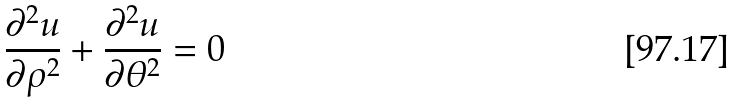Convert formula to latex. <formula><loc_0><loc_0><loc_500><loc_500>\frac { \partial ^ { 2 } u } { \partial \rho ^ { 2 } } + \frac { \partial ^ { 2 } u } { \partial \theta ^ { 2 } } = 0</formula> 